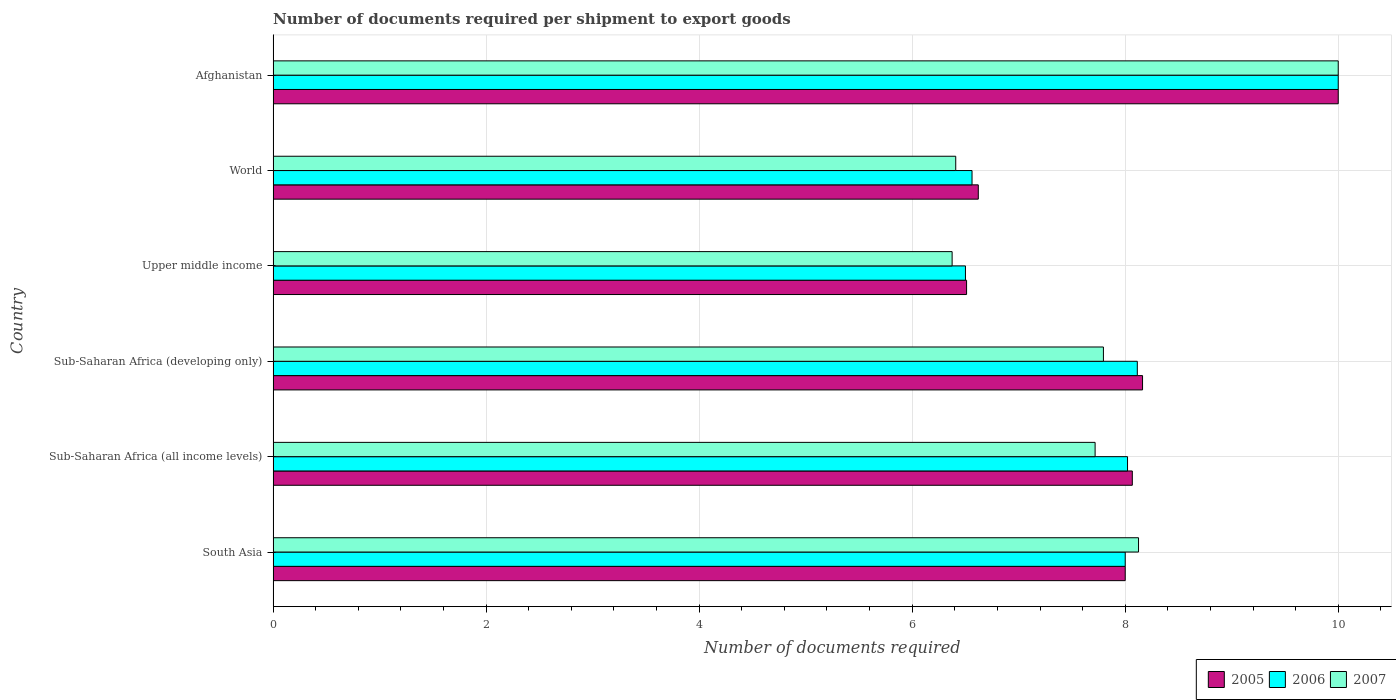Are the number of bars on each tick of the Y-axis equal?
Provide a succinct answer. Yes. How many bars are there on the 1st tick from the bottom?
Provide a succinct answer. 3. What is the label of the 1st group of bars from the top?
Make the answer very short. Afghanistan. Across all countries, what is the maximum number of documents required per shipment to export goods in 2006?
Offer a very short reply. 10. Across all countries, what is the minimum number of documents required per shipment to export goods in 2007?
Make the answer very short. 6.38. In which country was the number of documents required per shipment to export goods in 2005 maximum?
Give a very brief answer. Afghanistan. In which country was the number of documents required per shipment to export goods in 2007 minimum?
Your response must be concise. Upper middle income. What is the total number of documents required per shipment to export goods in 2007 in the graph?
Keep it short and to the point. 46.42. What is the difference between the number of documents required per shipment to export goods in 2007 in Afghanistan and that in World?
Offer a very short reply. 3.59. What is the difference between the number of documents required per shipment to export goods in 2006 in Upper middle income and the number of documents required per shipment to export goods in 2007 in Afghanistan?
Provide a succinct answer. -3.5. What is the average number of documents required per shipment to export goods in 2005 per country?
Your response must be concise. 7.89. What is the difference between the number of documents required per shipment to export goods in 2006 and number of documents required per shipment to export goods in 2007 in Sub-Saharan Africa (all income levels)?
Ensure brevity in your answer.  0.3. What is the ratio of the number of documents required per shipment to export goods in 2005 in Sub-Saharan Africa (all income levels) to that in Sub-Saharan Africa (developing only)?
Keep it short and to the point. 0.99. Is the number of documents required per shipment to export goods in 2007 in South Asia less than that in Sub-Saharan Africa (developing only)?
Offer a very short reply. No. Is the difference between the number of documents required per shipment to export goods in 2006 in Sub-Saharan Africa (developing only) and Upper middle income greater than the difference between the number of documents required per shipment to export goods in 2007 in Sub-Saharan Africa (developing only) and Upper middle income?
Ensure brevity in your answer.  Yes. What is the difference between the highest and the second highest number of documents required per shipment to export goods in 2006?
Keep it short and to the point. 1.89. Is the sum of the number of documents required per shipment to export goods in 2006 in Sub-Saharan Africa (all income levels) and World greater than the maximum number of documents required per shipment to export goods in 2005 across all countries?
Your answer should be very brief. Yes. What does the 1st bar from the bottom in Sub-Saharan Africa (all income levels) represents?
Give a very brief answer. 2005. How many bars are there?
Keep it short and to the point. 18. Are all the bars in the graph horizontal?
Ensure brevity in your answer.  Yes. How many countries are there in the graph?
Offer a very short reply. 6. Does the graph contain grids?
Provide a succinct answer. Yes. Where does the legend appear in the graph?
Your response must be concise. Bottom right. How many legend labels are there?
Ensure brevity in your answer.  3. How are the legend labels stacked?
Keep it short and to the point. Horizontal. What is the title of the graph?
Provide a succinct answer. Number of documents required per shipment to export goods. Does "1973" appear as one of the legend labels in the graph?
Give a very brief answer. No. What is the label or title of the X-axis?
Provide a short and direct response. Number of documents required. What is the label or title of the Y-axis?
Keep it short and to the point. Country. What is the Number of documents required of 2005 in South Asia?
Provide a short and direct response. 8. What is the Number of documents required of 2007 in South Asia?
Offer a terse response. 8.12. What is the Number of documents required of 2005 in Sub-Saharan Africa (all income levels)?
Your response must be concise. 8.07. What is the Number of documents required in 2006 in Sub-Saharan Africa (all income levels)?
Keep it short and to the point. 8.02. What is the Number of documents required in 2007 in Sub-Saharan Africa (all income levels)?
Keep it short and to the point. 7.72. What is the Number of documents required in 2005 in Sub-Saharan Africa (developing only)?
Your answer should be very brief. 8.16. What is the Number of documents required in 2006 in Sub-Saharan Africa (developing only)?
Give a very brief answer. 8.11. What is the Number of documents required in 2007 in Sub-Saharan Africa (developing only)?
Offer a terse response. 7.8. What is the Number of documents required in 2005 in Upper middle income?
Your response must be concise. 6.51. What is the Number of documents required of 2007 in Upper middle income?
Offer a very short reply. 6.38. What is the Number of documents required in 2005 in World?
Your response must be concise. 6.62. What is the Number of documents required in 2006 in World?
Offer a very short reply. 6.56. What is the Number of documents required of 2007 in World?
Offer a terse response. 6.41. What is the Number of documents required of 2005 in Afghanistan?
Your response must be concise. 10. What is the Number of documents required of 2007 in Afghanistan?
Provide a short and direct response. 10. Across all countries, what is the maximum Number of documents required of 2006?
Provide a short and direct response. 10. Across all countries, what is the maximum Number of documents required in 2007?
Give a very brief answer. 10. Across all countries, what is the minimum Number of documents required of 2005?
Your answer should be very brief. 6.51. Across all countries, what is the minimum Number of documents required of 2007?
Your answer should be very brief. 6.38. What is the total Number of documents required in 2005 in the graph?
Keep it short and to the point. 47.36. What is the total Number of documents required of 2006 in the graph?
Your answer should be very brief. 47.2. What is the total Number of documents required in 2007 in the graph?
Offer a very short reply. 46.42. What is the difference between the Number of documents required in 2005 in South Asia and that in Sub-Saharan Africa (all income levels)?
Your answer should be compact. -0.07. What is the difference between the Number of documents required in 2006 in South Asia and that in Sub-Saharan Africa (all income levels)?
Provide a short and direct response. -0.02. What is the difference between the Number of documents required of 2007 in South Asia and that in Sub-Saharan Africa (all income levels)?
Ensure brevity in your answer.  0.41. What is the difference between the Number of documents required of 2005 in South Asia and that in Sub-Saharan Africa (developing only)?
Provide a short and direct response. -0.16. What is the difference between the Number of documents required of 2006 in South Asia and that in Sub-Saharan Africa (developing only)?
Offer a very short reply. -0.11. What is the difference between the Number of documents required of 2007 in South Asia and that in Sub-Saharan Africa (developing only)?
Offer a very short reply. 0.33. What is the difference between the Number of documents required in 2005 in South Asia and that in Upper middle income?
Offer a very short reply. 1.49. What is the difference between the Number of documents required in 2006 in South Asia and that in Upper middle income?
Make the answer very short. 1.5. What is the difference between the Number of documents required in 2007 in South Asia and that in Upper middle income?
Offer a terse response. 1.75. What is the difference between the Number of documents required in 2005 in South Asia and that in World?
Offer a terse response. 1.38. What is the difference between the Number of documents required of 2006 in South Asia and that in World?
Ensure brevity in your answer.  1.44. What is the difference between the Number of documents required in 2007 in South Asia and that in World?
Provide a succinct answer. 1.72. What is the difference between the Number of documents required in 2007 in South Asia and that in Afghanistan?
Ensure brevity in your answer.  -1.88. What is the difference between the Number of documents required in 2005 in Sub-Saharan Africa (all income levels) and that in Sub-Saharan Africa (developing only)?
Give a very brief answer. -0.1. What is the difference between the Number of documents required of 2006 in Sub-Saharan Africa (all income levels) and that in Sub-Saharan Africa (developing only)?
Provide a short and direct response. -0.09. What is the difference between the Number of documents required in 2007 in Sub-Saharan Africa (all income levels) and that in Sub-Saharan Africa (developing only)?
Ensure brevity in your answer.  -0.08. What is the difference between the Number of documents required in 2005 in Sub-Saharan Africa (all income levels) and that in Upper middle income?
Provide a short and direct response. 1.56. What is the difference between the Number of documents required in 2006 in Sub-Saharan Africa (all income levels) and that in Upper middle income?
Provide a short and direct response. 1.52. What is the difference between the Number of documents required in 2007 in Sub-Saharan Africa (all income levels) and that in Upper middle income?
Give a very brief answer. 1.34. What is the difference between the Number of documents required of 2005 in Sub-Saharan Africa (all income levels) and that in World?
Ensure brevity in your answer.  1.45. What is the difference between the Number of documents required of 2006 in Sub-Saharan Africa (all income levels) and that in World?
Ensure brevity in your answer.  1.46. What is the difference between the Number of documents required in 2007 in Sub-Saharan Africa (all income levels) and that in World?
Give a very brief answer. 1.31. What is the difference between the Number of documents required of 2005 in Sub-Saharan Africa (all income levels) and that in Afghanistan?
Provide a succinct answer. -1.93. What is the difference between the Number of documents required in 2006 in Sub-Saharan Africa (all income levels) and that in Afghanistan?
Your answer should be compact. -1.98. What is the difference between the Number of documents required in 2007 in Sub-Saharan Africa (all income levels) and that in Afghanistan?
Your answer should be very brief. -2.28. What is the difference between the Number of documents required of 2005 in Sub-Saharan Africa (developing only) and that in Upper middle income?
Offer a terse response. 1.65. What is the difference between the Number of documents required of 2006 in Sub-Saharan Africa (developing only) and that in Upper middle income?
Ensure brevity in your answer.  1.61. What is the difference between the Number of documents required of 2007 in Sub-Saharan Africa (developing only) and that in Upper middle income?
Provide a short and direct response. 1.42. What is the difference between the Number of documents required in 2005 in Sub-Saharan Africa (developing only) and that in World?
Provide a succinct answer. 1.54. What is the difference between the Number of documents required in 2006 in Sub-Saharan Africa (developing only) and that in World?
Your answer should be very brief. 1.55. What is the difference between the Number of documents required in 2007 in Sub-Saharan Africa (developing only) and that in World?
Keep it short and to the point. 1.39. What is the difference between the Number of documents required of 2005 in Sub-Saharan Africa (developing only) and that in Afghanistan?
Provide a short and direct response. -1.84. What is the difference between the Number of documents required in 2006 in Sub-Saharan Africa (developing only) and that in Afghanistan?
Your answer should be compact. -1.89. What is the difference between the Number of documents required of 2007 in Sub-Saharan Africa (developing only) and that in Afghanistan?
Offer a terse response. -2.2. What is the difference between the Number of documents required in 2005 in Upper middle income and that in World?
Offer a terse response. -0.11. What is the difference between the Number of documents required of 2006 in Upper middle income and that in World?
Keep it short and to the point. -0.06. What is the difference between the Number of documents required in 2007 in Upper middle income and that in World?
Your answer should be compact. -0.03. What is the difference between the Number of documents required in 2005 in Upper middle income and that in Afghanistan?
Keep it short and to the point. -3.49. What is the difference between the Number of documents required of 2007 in Upper middle income and that in Afghanistan?
Make the answer very short. -3.62. What is the difference between the Number of documents required in 2005 in World and that in Afghanistan?
Your answer should be very brief. -3.38. What is the difference between the Number of documents required of 2006 in World and that in Afghanistan?
Offer a very short reply. -3.44. What is the difference between the Number of documents required in 2007 in World and that in Afghanistan?
Offer a terse response. -3.59. What is the difference between the Number of documents required in 2005 in South Asia and the Number of documents required in 2006 in Sub-Saharan Africa (all income levels)?
Your answer should be compact. -0.02. What is the difference between the Number of documents required of 2005 in South Asia and the Number of documents required of 2007 in Sub-Saharan Africa (all income levels)?
Keep it short and to the point. 0.28. What is the difference between the Number of documents required in 2006 in South Asia and the Number of documents required in 2007 in Sub-Saharan Africa (all income levels)?
Offer a very short reply. 0.28. What is the difference between the Number of documents required in 2005 in South Asia and the Number of documents required in 2006 in Sub-Saharan Africa (developing only)?
Give a very brief answer. -0.11. What is the difference between the Number of documents required in 2005 in South Asia and the Number of documents required in 2007 in Sub-Saharan Africa (developing only)?
Provide a succinct answer. 0.2. What is the difference between the Number of documents required of 2006 in South Asia and the Number of documents required of 2007 in Sub-Saharan Africa (developing only)?
Provide a short and direct response. 0.2. What is the difference between the Number of documents required of 2005 in South Asia and the Number of documents required of 2006 in Upper middle income?
Offer a terse response. 1.5. What is the difference between the Number of documents required in 2005 in South Asia and the Number of documents required in 2007 in Upper middle income?
Your answer should be very brief. 1.62. What is the difference between the Number of documents required of 2006 in South Asia and the Number of documents required of 2007 in Upper middle income?
Give a very brief answer. 1.62. What is the difference between the Number of documents required in 2005 in South Asia and the Number of documents required in 2006 in World?
Ensure brevity in your answer.  1.44. What is the difference between the Number of documents required of 2005 in South Asia and the Number of documents required of 2007 in World?
Your response must be concise. 1.59. What is the difference between the Number of documents required in 2006 in South Asia and the Number of documents required in 2007 in World?
Provide a succinct answer. 1.59. What is the difference between the Number of documents required in 2005 in South Asia and the Number of documents required in 2006 in Afghanistan?
Offer a terse response. -2. What is the difference between the Number of documents required of 2005 in South Asia and the Number of documents required of 2007 in Afghanistan?
Your response must be concise. -2. What is the difference between the Number of documents required in 2006 in South Asia and the Number of documents required in 2007 in Afghanistan?
Offer a very short reply. -2. What is the difference between the Number of documents required of 2005 in Sub-Saharan Africa (all income levels) and the Number of documents required of 2006 in Sub-Saharan Africa (developing only)?
Offer a very short reply. -0.05. What is the difference between the Number of documents required of 2005 in Sub-Saharan Africa (all income levels) and the Number of documents required of 2007 in Sub-Saharan Africa (developing only)?
Give a very brief answer. 0.27. What is the difference between the Number of documents required in 2006 in Sub-Saharan Africa (all income levels) and the Number of documents required in 2007 in Sub-Saharan Africa (developing only)?
Your answer should be very brief. 0.23. What is the difference between the Number of documents required of 2005 in Sub-Saharan Africa (all income levels) and the Number of documents required of 2006 in Upper middle income?
Your answer should be compact. 1.57. What is the difference between the Number of documents required in 2005 in Sub-Saharan Africa (all income levels) and the Number of documents required in 2007 in Upper middle income?
Provide a succinct answer. 1.69. What is the difference between the Number of documents required of 2006 in Sub-Saharan Africa (all income levels) and the Number of documents required of 2007 in Upper middle income?
Your answer should be very brief. 1.65. What is the difference between the Number of documents required of 2005 in Sub-Saharan Africa (all income levels) and the Number of documents required of 2006 in World?
Give a very brief answer. 1.5. What is the difference between the Number of documents required in 2005 in Sub-Saharan Africa (all income levels) and the Number of documents required in 2007 in World?
Give a very brief answer. 1.66. What is the difference between the Number of documents required in 2006 in Sub-Saharan Africa (all income levels) and the Number of documents required in 2007 in World?
Provide a succinct answer. 1.61. What is the difference between the Number of documents required of 2005 in Sub-Saharan Africa (all income levels) and the Number of documents required of 2006 in Afghanistan?
Your answer should be compact. -1.93. What is the difference between the Number of documents required of 2005 in Sub-Saharan Africa (all income levels) and the Number of documents required of 2007 in Afghanistan?
Your answer should be compact. -1.93. What is the difference between the Number of documents required of 2006 in Sub-Saharan Africa (all income levels) and the Number of documents required of 2007 in Afghanistan?
Ensure brevity in your answer.  -1.98. What is the difference between the Number of documents required in 2005 in Sub-Saharan Africa (developing only) and the Number of documents required in 2006 in Upper middle income?
Ensure brevity in your answer.  1.66. What is the difference between the Number of documents required in 2005 in Sub-Saharan Africa (developing only) and the Number of documents required in 2007 in Upper middle income?
Offer a very short reply. 1.79. What is the difference between the Number of documents required in 2006 in Sub-Saharan Africa (developing only) and the Number of documents required in 2007 in Upper middle income?
Your answer should be compact. 1.74. What is the difference between the Number of documents required in 2005 in Sub-Saharan Africa (developing only) and the Number of documents required in 2006 in World?
Your answer should be compact. 1.6. What is the difference between the Number of documents required in 2005 in Sub-Saharan Africa (developing only) and the Number of documents required in 2007 in World?
Ensure brevity in your answer.  1.75. What is the difference between the Number of documents required in 2006 in Sub-Saharan Africa (developing only) and the Number of documents required in 2007 in World?
Provide a succinct answer. 1.7. What is the difference between the Number of documents required in 2005 in Sub-Saharan Africa (developing only) and the Number of documents required in 2006 in Afghanistan?
Ensure brevity in your answer.  -1.84. What is the difference between the Number of documents required in 2005 in Sub-Saharan Africa (developing only) and the Number of documents required in 2007 in Afghanistan?
Offer a terse response. -1.84. What is the difference between the Number of documents required of 2006 in Sub-Saharan Africa (developing only) and the Number of documents required of 2007 in Afghanistan?
Give a very brief answer. -1.89. What is the difference between the Number of documents required in 2005 in Upper middle income and the Number of documents required in 2006 in World?
Offer a very short reply. -0.05. What is the difference between the Number of documents required of 2005 in Upper middle income and the Number of documents required of 2007 in World?
Your response must be concise. 0.1. What is the difference between the Number of documents required in 2006 in Upper middle income and the Number of documents required in 2007 in World?
Give a very brief answer. 0.09. What is the difference between the Number of documents required in 2005 in Upper middle income and the Number of documents required in 2006 in Afghanistan?
Your answer should be very brief. -3.49. What is the difference between the Number of documents required of 2005 in Upper middle income and the Number of documents required of 2007 in Afghanistan?
Make the answer very short. -3.49. What is the difference between the Number of documents required of 2006 in Upper middle income and the Number of documents required of 2007 in Afghanistan?
Make the answer very short. -3.5. What is the difference between the Number of documents required in 2005 in World and the Number of documents required in 2006 in Afghanistan?
Provide a short and direct response. -3.38. What is the difference between the Number of documents required in 2005 in World and the Number of documents required in 2007 in Afghanistan?
Provide a short and direct response. -3.38. What is the difference between the Number of documents required of 2006 in World and the Number of documents required of 2007 in Afghanistan?
Your answer should be compact. -3.44. What is the average Number of documents required in 2005 per country?
Ensure brevity in your answer.  7.89. What is the average Number of documents required of 2006 per country?
Your answer should be compact. 7.87. What is the average Number of documents required of 2007 per country?
Give a very brief answer. 7.74. What is the difference between the Number of documents required in 2005 and Number of documents required in 2007 in South Asia?
Make the answer very short. -0.12. What is the difference between the Number of documents required of 2006 and Number of documents required of 2007 in South Asia?
Your response must be concise. -0.12. What is the difference between the Number of documents required of 2005 and Number of documents required of 2006 in Sub-Saharan Africa (all income levels)?
Ensure brevity in your answer.  0.04. What is the difference between the Number of documents required in 2005 and Number of documents required in 2007 in Sub-Saharan Africa (all income levels)?
Provide a short and direct response. 0.35. What is the difference between the Number of documents required of 2006 and Number of documents required of 2007 in Sub-Saharan Africa (all income levels)?
Offer a very short reply. 0.3. What is the difference between the Number of documents required in 2005 and Number of documents required in 2006 in Sub-Saharan Africa (developing only)?
Your answer should be very brief. 0.05. What is the difference between the Number of documents required of 2005 and Number of documents required of 2007 in Sub-Saharan Africa (developing only)?
Offer a terse response. 0.37. What is the difference between the Number of documents required in 2006 and Number of documents required in 2007 in Sub-Saharan Africa (developing only)?
Make the answer very short. 0.32. What is the difference between the Number of documents required of 2005 and Number of documents required of 2006 in Upper middle income?
Keep it short and to the point. 0.01. What is the difference between the Number of documents required of 2005 and Number of documents required of 2007 in Upper middle income?
Your answer should be very brief. 0.14. What is the difference between the Number of documents required of 2006 and Number of documents required of 2007 in Upper middle income?
Your response must be concise. 0.12. What is the difference between the Number of documents required in 2005 and Number of documents required in 2006 in World?
Your answer should be very brief. 0.06. What is the difference between the Number of documents required in 2005 and Number of documents required in 2007 in World?
Give a very brief answer. 0.21. What is the difference between the Number of documents required in 2006 and Number of documents required in 2007 in World?
Offer a very short reply. 0.15. What is the difference between the Number of documents required of 2006 and Number of documents required of 2007 in Afghanistan?
Your answer should be compact. 0. What is the ratio of the Number of documents required of 2005 in South Asia to that in Sub-Saharan Africa (all income levels)?
Offer a terse response. 0.99. What is the ratio of the Number of documents required in 2006 in South Asia to that in Sub-Saharan Africa (all income levels)?
Your response must be concise. 1. What is the ratio of the Number of documents required in 2007 in South Asia to that in Sub-Saharan Africa (all income levels)?
Offer a terse response. 1.05. What is the ratio of the Number of documents required of 2005 in South Asia to that in Sub-Saharan Africa (developing only)?
Your answer should be very brief. 0.98. What is the ratio of the Number of documents required in 2006 in South Asia to that in Sub-Saharan Africa (developing only)?
Your response must be concise. 0.99. What is the ratio of the Number of documents required in 2007 in South Asia to that in Sub-Saharan Africa (developing only)?
Keep it short and to the point. 1.04. What is the ratio of the Number of documents required of 2005 in South Asia to that in Upper middle income?
Ensure brevity in your answer.  1.23. What is the ratio of the Number of documents required of 2006 in South Asia to that in Upper middle income?
Give a very brief answer. 1.23. What is the ratio of the Number of documents required in 2007 in South Asia to that in Upper middle income?
Provide a short and direct response. 1.27. What is the ratio of the Number of documents required in 2005 in South Asia to that in World?
Your answer should be very brief. 1.21. What is the ratio of the Number of documents required in 2006 in South Asia to that in World?
Ensure brevity in your answer.  1.22. What is the ratio of the Number of documents required in 2007 in South Asia to that in World?
Ensure brevity in your answer.  1.27. What is the ratio of the Number of documents required in 2005 in South Asia to that in Afghanistan?
Give a very brief answer. 0.8. What is the ratio of the Number of documents required in 2007 in South Asia to that in Afghanistan?
Keep it short and to the point. 0.81. What is the ratio of the Number of documents required of 2006 in Sub-Saharan Africa (all income levels) to that in Sub-Saharan Africa (developing only)?
Make the answer very short. 0.99. What is the ratio of the Number of documents required in 2005 in Sub-Saharan Africa (all income levels) to that in Upper middle income?
Your response must be concise. 1.24. What is the ratio of the Number of documents required of 2006 in Sub-Saharan Africa (all income levels) to that in Upper middle income?
Give a very brief answer. 1.23. What is the ratio of the Number of documents required in 2007 in Sub-Saharan Africa (all income levels) to that in Upper middle income?
Your response must be concise. 1.21. What is the ratio of the Number of documents required in 2005 in Sub-Saharan Africa (all income levels) to that in World?
Give a very brief answer. 1.22. What is the ratio of the Number of documents required of 2006 in Sub-Saharan Africa (all income levels) to that in World?
Ensure brevity in your answer.  1.22. What is the ratio of the Number of documents required in 2007 in Sub-Saharan Africa (all income levels) to that in World?
Ensure brevity in your answer.  1.2. What is the ratio of the Number of documents required of 2005 in Sub-Saharan Africa (all income levels) to that in Afghanistan?
Ensure brevity in your answer.  0.81. What is the ratio of the Number of documents required in 2006 in Sub-Saharan Africa (all income levels) to that in Afghanistan?
Provide a short and direct response. 0.8. What is the ratio of the Number of documents required in 2007 in Sub-Saharan Africa (all income levels) to that in Afghanistan?
Provide a succinct answer. 0.77. What is the ratio of the Number of documents required in 2005 in Sub-Saharan Africa (developing only) to that in Upper middle income?
Provide a succinct answer. 1.25. What is the ratio of the Number of documents required in 2006 in Sub-Saharan Africa (developing only) to that in Upper middle income?
Ensure brevity in your answer.  1.25. What is the ratio of the Number of documents required of 2007 in Sub-Saharan Africa (developing only) to that in Upper middle income?
Ensure brevity in your answer.  1.22. What is the ratio of the Number of documents required of 2005 in Sub-Saharan Africa (developing only) to that in World?
Your response must be concise. 1.23. What is the ratio of the Number of documents required in 2006 in Sub-Saharan Africa (developing only) to that in World?
Offer a terse response. 1.24. What is the ratio of the Number of documents required in 2007 in Sub-Saharan Africa (developing only) to that in World?
Ensure brevity in your answer.  1.22. What is the ratio of the Number of documents required of 2005 in Sub-Saharan Africa (developing only) to that in Afghanistan?
Offer a terse response. 0.82. What is the ratio of the Number of documents required of 2006 in Sub-Saharan Africa (developing only) to that in Afghanistan?
Provide a short and direct response. 0.81. What is the ratio of the Number of documents required in 2007 in Sub-Saharan Africa (developing only) to that in Afghanistan?
Ensure brevity in your answer.  0.78. What is the ratio of the Number of documents required in 2005 in Upper middle income to that in World?
Your answer should be compact. 0.98. What is the ratio of the Number of documents required in 2006 in Upper middle income to that in World?
Ensure brevity in your answer.  0.99. What is the ratio of the Number of documents required in 2005 in Upper middle income to that in Afghanistan?
Give a very brief answer. 0.65. What is the ratio of the Number of documents required in 2006 in Upper middle income to that in Afghanistan?
Ensure brevity in your answer.  0.65. What is the ratio of the Number of documents required of 2007 in Upper middle income to that in Afghanistan?
Ensure brevity in your answer.  0.64. What is the ratio of the Number of documents required in 2005 in World to that in Afghanistan?
Offer a very short reply. 0.66. What is the ratio of the Number of documents required of 2006 in World to that in Afghanistan?
Your answer should be compact. 0.66. What is the ratio of the Number of documents required of 2007 in World to that in Afghanistan?
Keep it short and to the point. 0.64. What is the difference between the highest and the second highest Number of documents required in 2005?
Keep it short and to the point. 1.84. What is the difference between the highest and the second highest Number of documents required of 2006?
Give a very brief answer. 1.89. What is the difference between the highest and the second highest Number of documents required in 2007?
Offer a terse response. 1.88. What is the difference between the highest and the lowest Number of documents required in 2005?
Provide a short and direct response. 3.49. What is the difference between the highest and the lowest Number of documents required in 2007?
Provide a succinct answer. 3.62. 